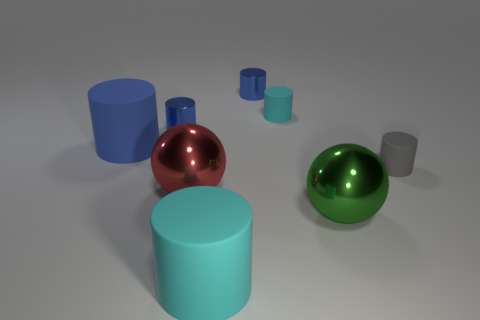The large cylinder that is in front of the gray rubber object in front of the small blue cylinder that is to the right of the large cyan matte cylinder is made of what material?
Offer a very short reply. Rubber. Is the number of large objects that are right of the large blue object greater than the number of large red shiny spheres?
Offer a very short reply. Yes. There is a blue thing that is the same size as the green object; what is it made of?
Provide a short and direct response. Rubber. Are there any gray matte objects of the same size as the red metal sphere?
Offer a very short reply. No. What size is the cyan thing behind the big green metallic ball?
Your answer should be compact. Small. What is the size of the blue matte cylinder?
Ensure brevity in your answer.  Large. How many cubes are small blue things or gray objects?
Provide a succinct answer. 0. What is the size of the other cyan object that is made of the same material as the big cyan thing?
Your response must be concise. Small. Are there any tiny blue cylinders left of the large green ball?
Ensure brevity in your answer.  Yes. Is the shape of the big blue matte thing the same as the shiny thing to the right of the small cyan rubber object?
Offer a very short reply. No. 